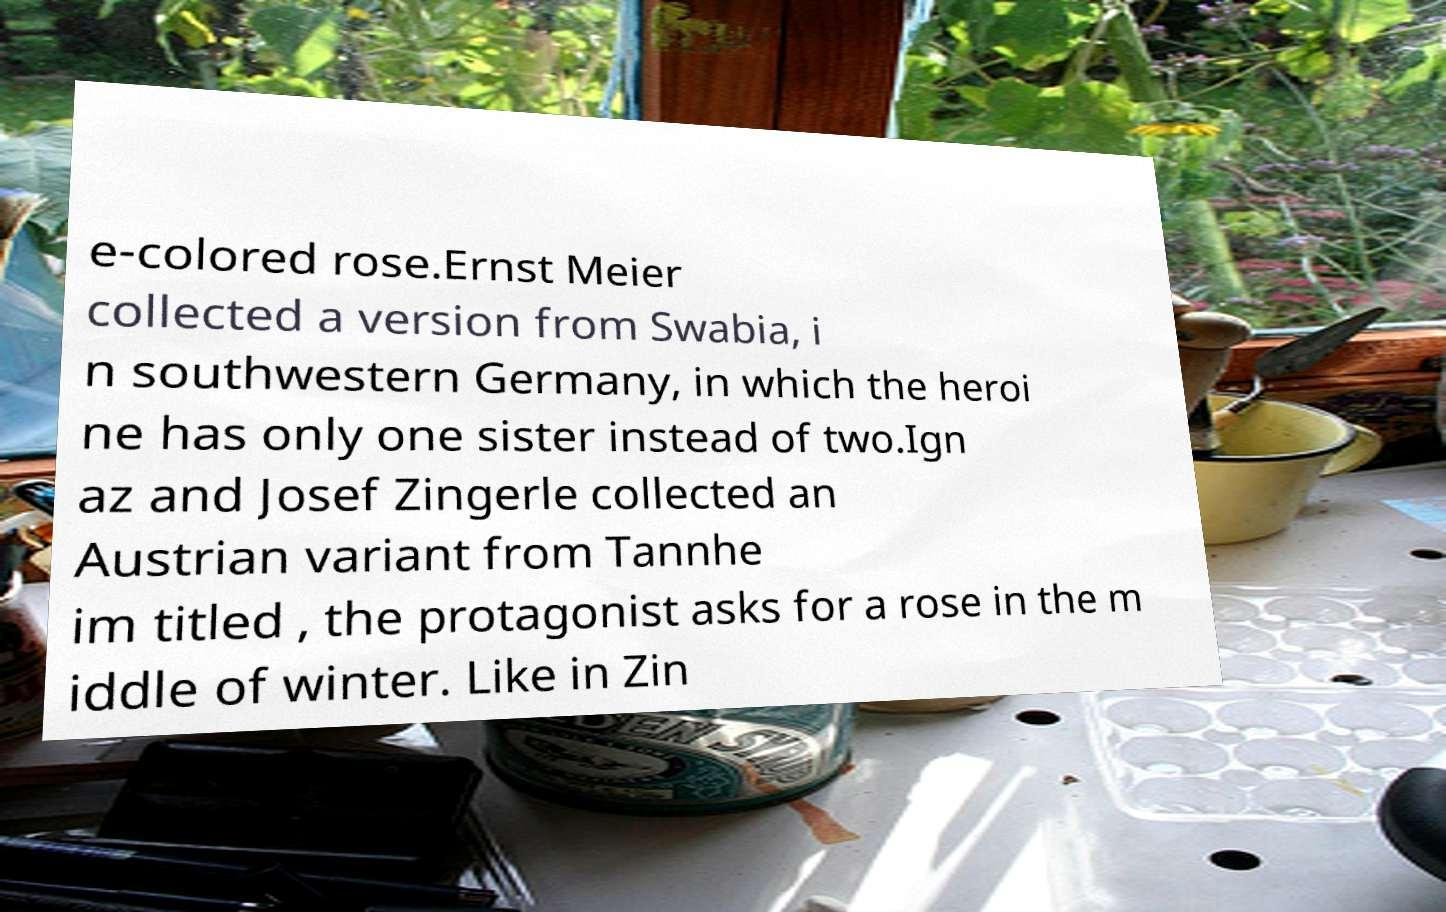For documentation purposes, I need the text within this image transcribed. Could you provide that? e-colored rose.Ernst Meier collected a version from Swabia, i n southwestern Germany, in which the heroi ne has only one sister instead of two.Ign az and Josef Zingerle collected an Austrian variant from Tannhe im titled , the protagonist asks for a rose in the m iddle of winter. Like in Zin 